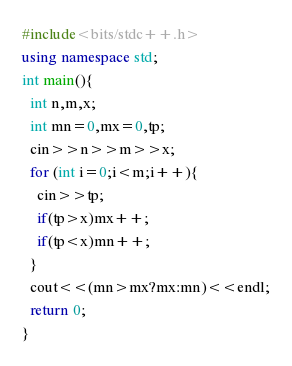<code> <loc_0><loc_0><loc_500><loc_500><_C++_>#include<bits/stdc++.h>
using namespace std;
int main(){
  int n,m,x;
  int mn=0,mx=0,tp;
  cin>>n>>m>>x;
  for (int i=0;i<m;i++){
    cin>>tp;
    if(tp>x)mx++;
    if(tp<x)mn++;
  }
  cout<<(mn>mx?mx:mn)<<endl;
  return 0;
}</code> 